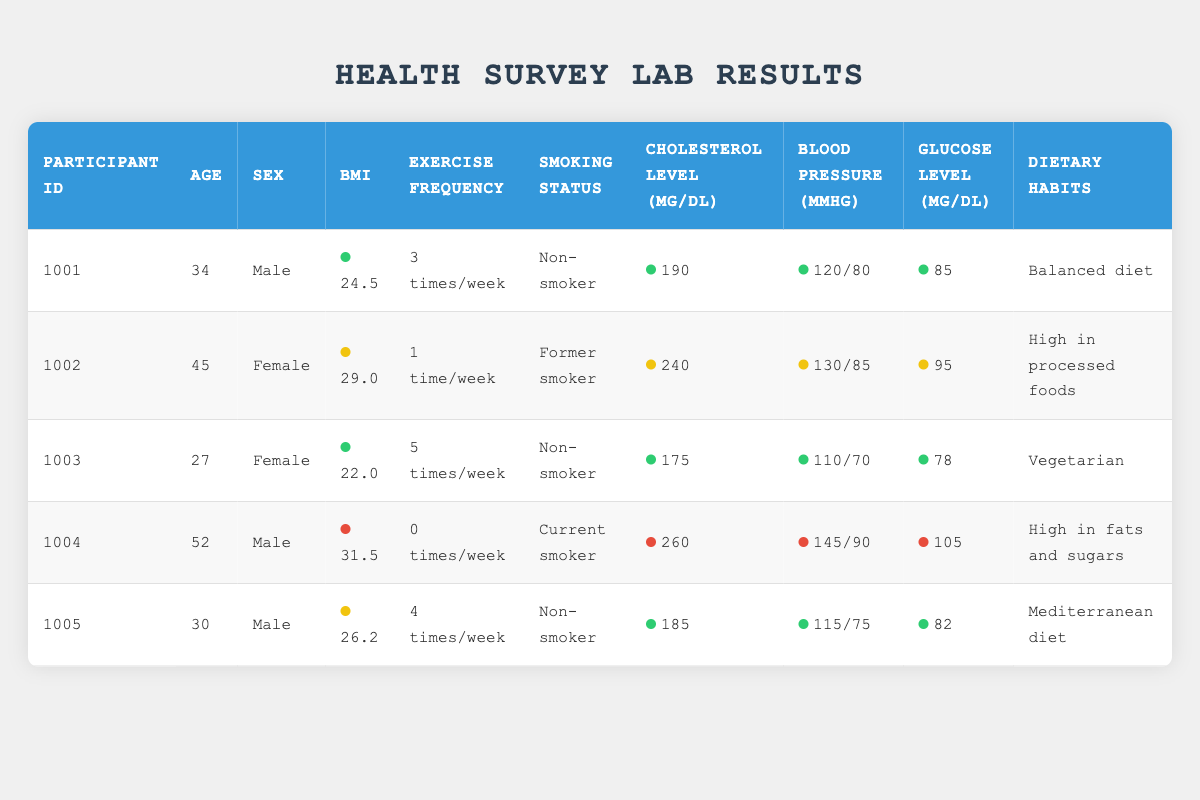What is the cholesterol level of Participant 1002? The cholesterol level is explicitly stated in the row for Participant 1002. Looking at the Cholesterol Level column, the value for Participant 1002 is 240 mg/dL.
Answer: 240 mg/dL How many times per week does Participant 1003 exercise? The exercise frequency for Participant 1003 is found in the Exercise Frequency column of the corresponding row. It shows that Participant 1003 exercises 5 times a week.
Answer: 5 times/week What is the average BMI of all participants? To calculate the average BMI, we need to sum the BMI values and then divide by the number of participants. The BMIs are 24.5, 29.0, 22.0, 31.5, and 26.2. The total sum is (24.5 + 29.0 + 22.0 + 31.5 + 26.2) = 133.2, and dividing by 5 gives us 133.2/5 = 26.64.
Answer: 26.64 Is Participant 1004 a non-smoker? Looking at the Smoking Status column, Participant 1004 is listed as a "Current smoker". Therefore, the answer is no.
Answer: No Which dietary habit is associated with the highest cholesterol level? We need to find out which participant has the highest cholesterol level in the Cholesterol Level column and then check their Dietary Habits. Participant 1004 has the highest cholesterol level at 260 mg/dL, and their dietary habit is "High in fats and sugars."
Answer: High in fats and sugars What is the blood pressure of the youngest participant? First, we need to identify the youngest participant by checking the Age column. Participant 1003 is the youngest at 27 years old. The corresponding blood pressure value in the Blood Pressure column for Participant 1003 is 110/70 mmHg.
Answer: 110/70 mmHg What percentage of the participants are non-smokers? First, we determine the total number of participants, which is 5. Next, we find the number of non-smokers: Participants 1001, 1003, and 1005 are non-smokers (3 out of 5). The percentage is calculated as (3/5) * 100 = 60%.
Answer: 60% What is the highest glucose level among the participants? The highest glucose level can be found in the Glucose Level column. The values for glucose levels are 85, 95, 78, 105, and 82. The maximum value among these is 105 mg/dL for Participant 1004.
Answer: 105 mg/dL How many participants have a BMI over 30? We filter the BMI column to check each participant's BMI value. Only Participant 1004 has a BMI over 30 (31.5). Hence, there is just one participant above that threshold.
Answer: 1 